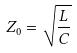<formula> <loc_0><loc_0><loc_500><loc_500>Z _ { 0 } = \sqrt { \frac { L } { C } }</formula> 